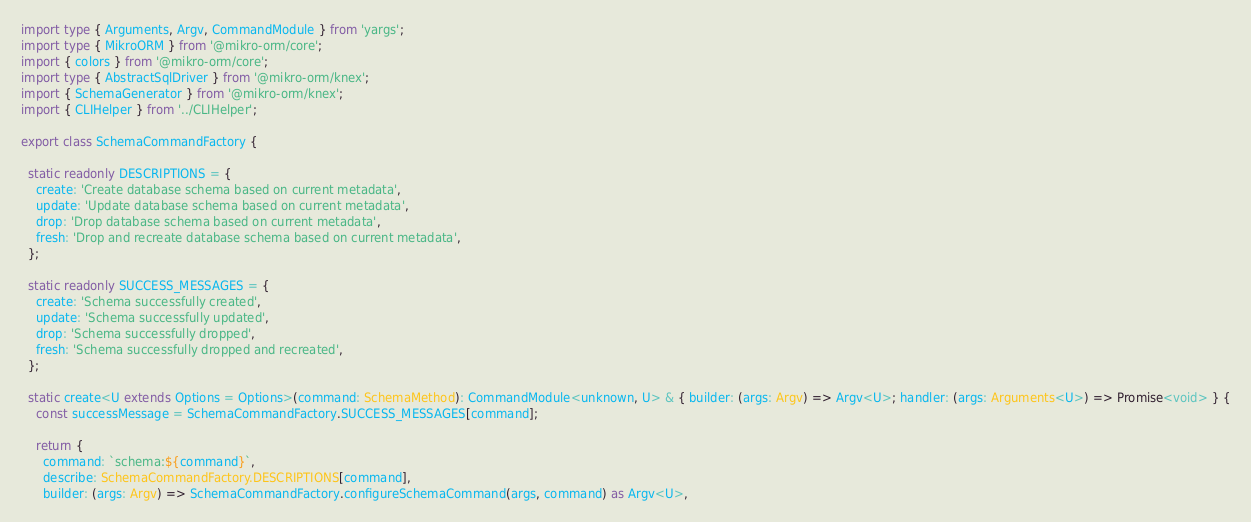Convert code to text. <code><loc_0><loc_0><loc_500><loc_500><_TypeScript_>import type { Arguments, Argv, CommandModule } from 'yargs';
import type { MikroORM } from '@mikro-orm/core';
import { colors } from '@mikro-orm/core';
import type { AbstractSqlDriver } from '@mikro-orm/knex';
import { SchemaGenerator } from '@mikro-orm/knex';
import { CLIHelper } from '../CLIHelper';

export class SchemaCommandFactory {

  static readonly DESCRIPTIONS = {
    create: 'Create database schema based on current metadata',
    update: 'Update database schema based on current metadata',
    drop: 'Drop database schema based on current metadata',
    fresh: 'Drop and recreate database schema based on current metadata',
  };

  static readonly SUCCESS_MESSAGES = {
    create: 'Schema successfully created',
    update: 'Schema successfully updated',
    drop: 'Schema successfully dropped',
    fresh: 'Schema successfully dropped and recreated',
  };

  static create<U extends Options = Options>(command: SchemaMethod): CommandModule<unknown, U> & { builder: (args: Argv) => Argv<U>; handler: (args: Arguments<U>) => Promise<void> } {
    const successMessage = SchemaCommandFactory.SUCCESS_MESSAGES[command];

    return {
      command: `schema:${command}`,
      describe: SchemaCommandFactory.DESCRIPTIONS[command],
      builder: (args: Argv) => SchemaCommandFactory.configureSchemaCommand(args, command) as Argv<U>,</code> 